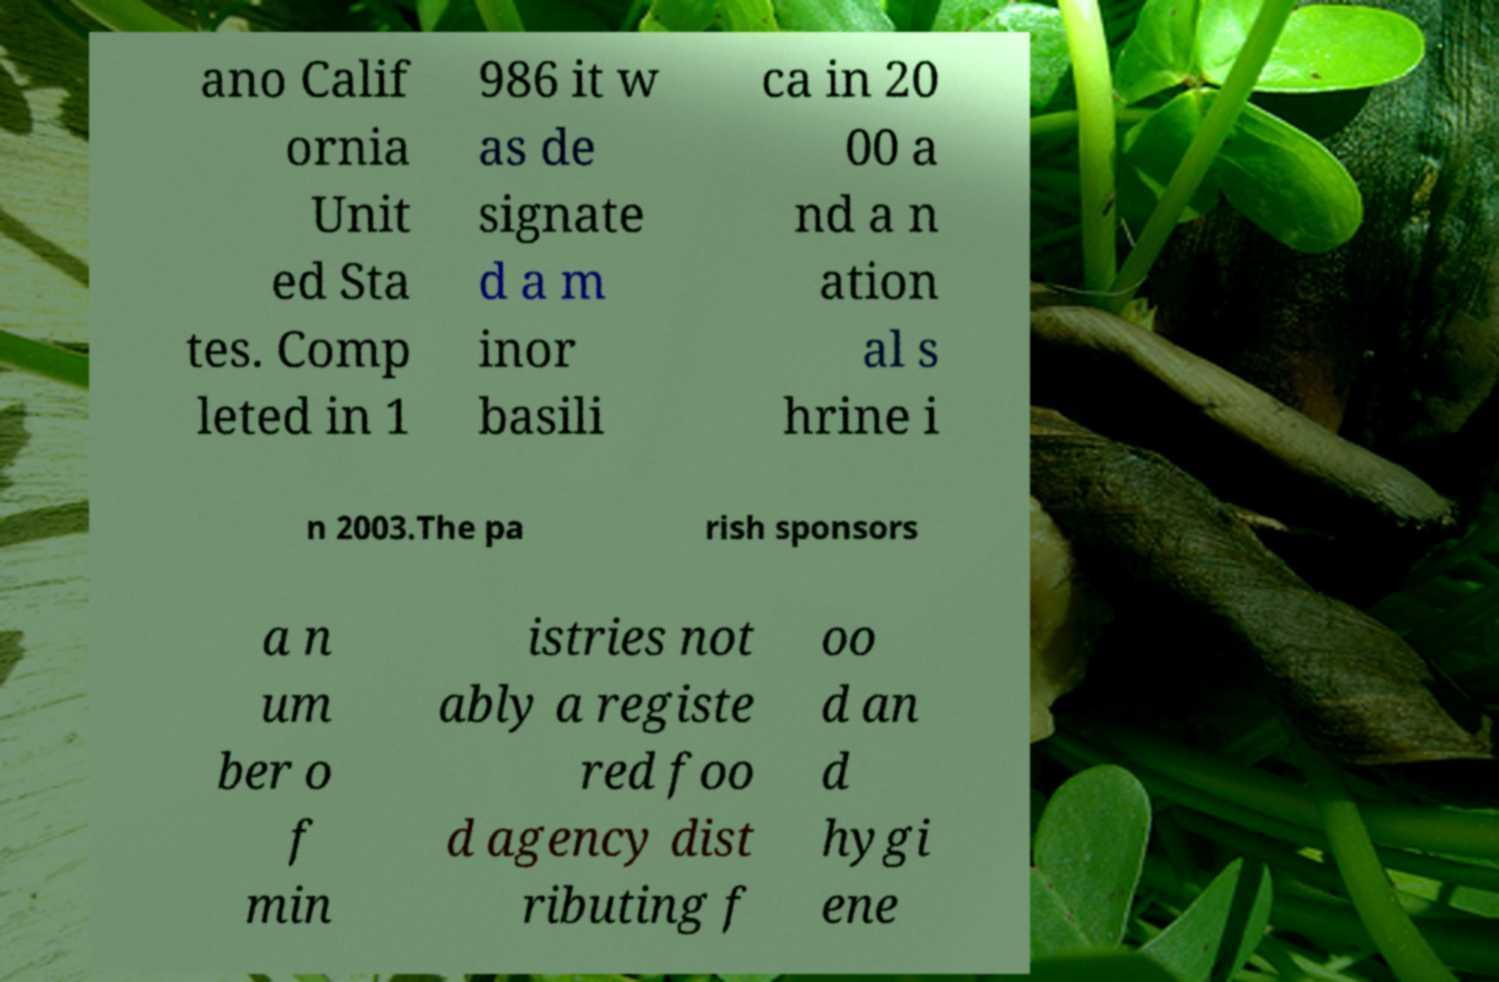Could you extract and type out the text from this image? ano Calif ornia Unit ed Sta tes. Comp leted in 1 986 it w as de signate d a m inor basili ca in 20 00 a nd a n ation al s hrine i n 2003.The pa rish sponsors a n um ber o f min istries not ably a registe red foo d agency dist ributing f oo d an d hygi ene 